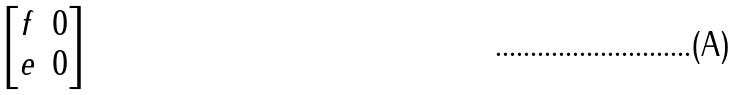<formula> <loc_0><loc_0><loc_500><loc_500>\begin{bmatrix} f & 0 \\ e & 0 \end{bmatrix}</formula> 